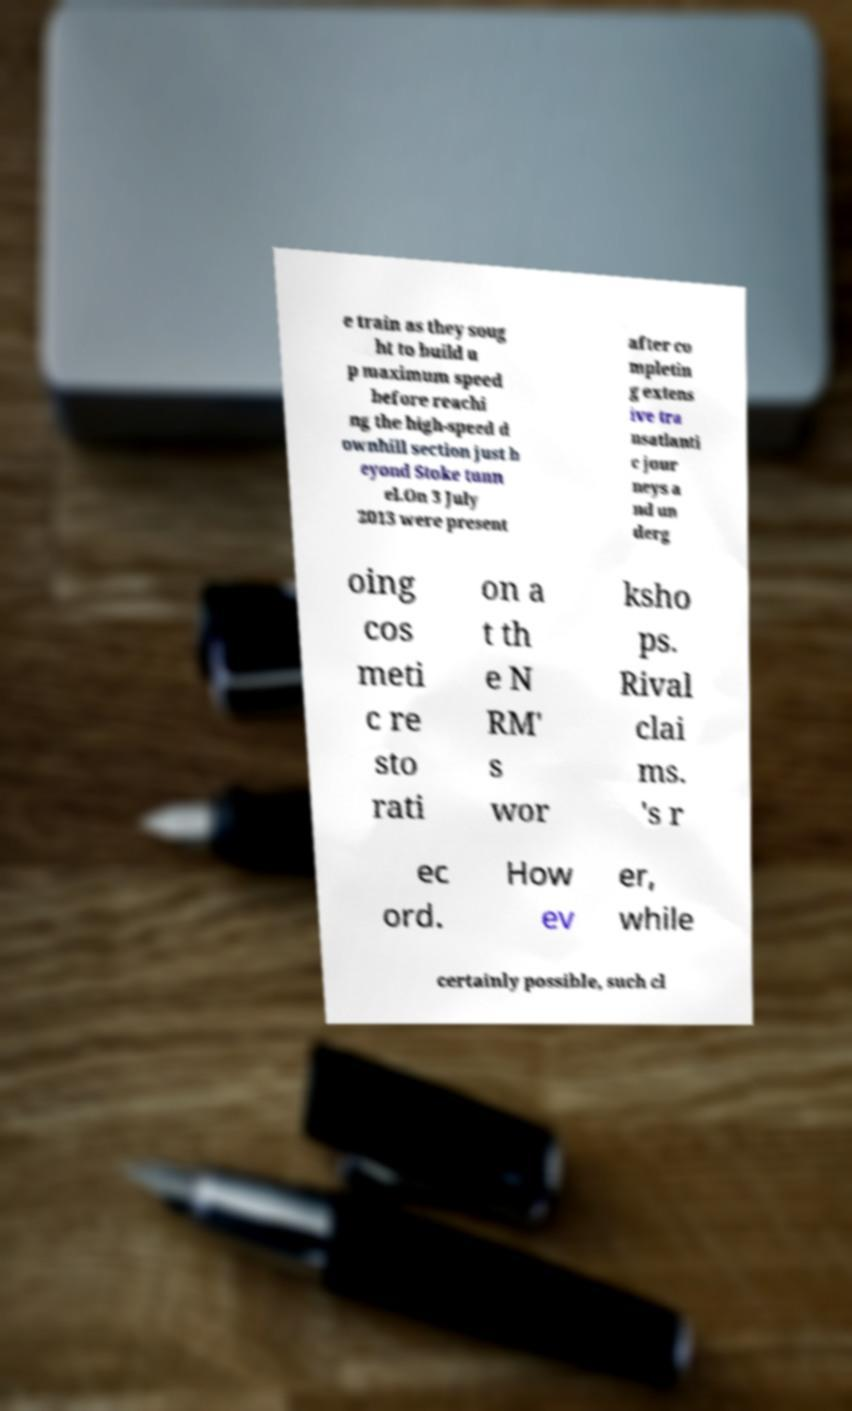I need the written content from this picture converted into text. Can you do that? e train as they soug ht to build u p maximum speed before reachi ng the high-speed d ownhill section just b eyond Stoke tunn el.On 3 July 2013 were present after co mpletin g extens ive tra nsatlanti c jour neys a nd un derg oing cos meti c re sto rati on a t th e N RM' s wor ksho ps. Rival clai ms. 's r ec ord. How ev er, while certainly possible, such cl 